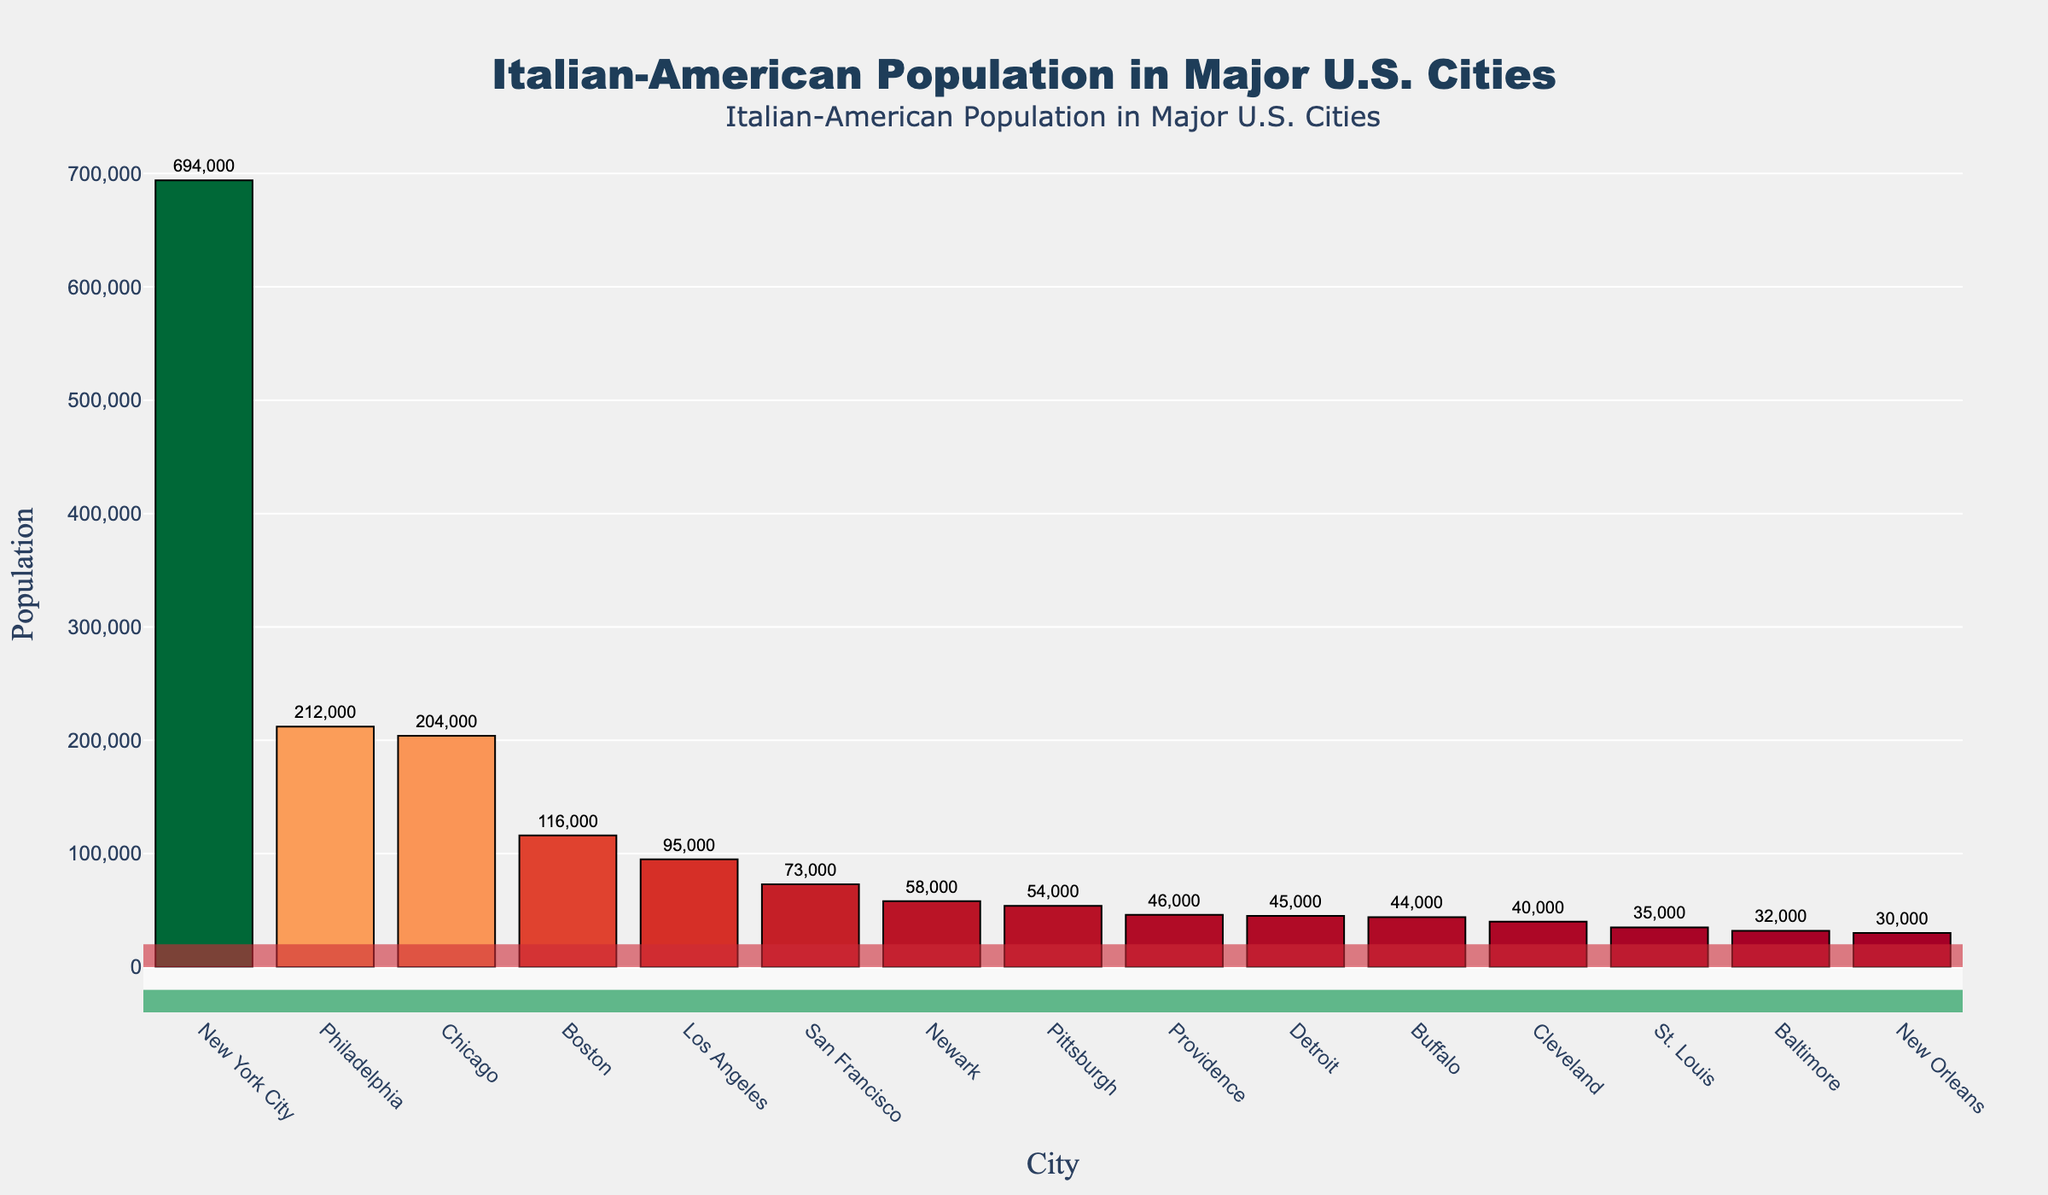Which city has the highest Italian-American population? Looking at the bar with the greatest height, New York City has the tallest bar, indicating it has the highest Italian-American population.
Answer: New York City Compare the Italian-American population of Chicago and Boston. Which city has more, and by how much? From the figure, Chicago has a bar with a higher value. Subtracting the population of Boston from Chicago (204,000 - 116,000) gives the difference.
Answer: Chicago by 88,000 What's the combined Italian-American population of Newark and Providence? Adding the populations of Newark (58,000) and Providence (46,000) gives the combined total.
Answer: 104,000 Which city has the smallest Italian-American population, and what is that population? The city with the shortest bar represents the smallest population. From the chart, New Orleans has the smallest Italian-American population of 30,000.
Answer: New Orleans, 30,000 Is the Italian-American population in Philadelphia more than twice that in Detroit? The population of Philadelphia is 212,000, while Detroit's is 45,000. Doubling Detroit’s population gives 90,000, which is less than Philadelphia's population.
Answer: Yes What is the difference in Italian-American population between Los Angeles and San Francisco? The population of Los Angeles is 95,000 and that of San Francisco is 73,000. Subtracting San Francisco’s population from Los Angeles' (95,000 - 73,000) gives the difference.
Answer: 22,000 Rank the top three cities in terms of Italian-American population. The three tallest bars represent the top three cities. They are New York City, Philadelphia, and Chicago in descending order of population.
Answer: New York City, Philadelphia, Chicago By how much is the Italian-American population of Boston greater than that of Baltimore? The population of Boston is 116,000 and that of Baltimore is 32,000. Subtracting Baltimore’s population from Boston's (116,000 - 32,000) gives the difference.
Answer: 84,000 What is the average population of Italian-Americans in Los Angeles, Detroit, and Cleveland? The populations are Los Angeles (95,000), Detroit (45,000), and Cleveland (40,000). Summing these gives 180,000, and averaging it over three cities gives 60,000.
Answer: 60,000 